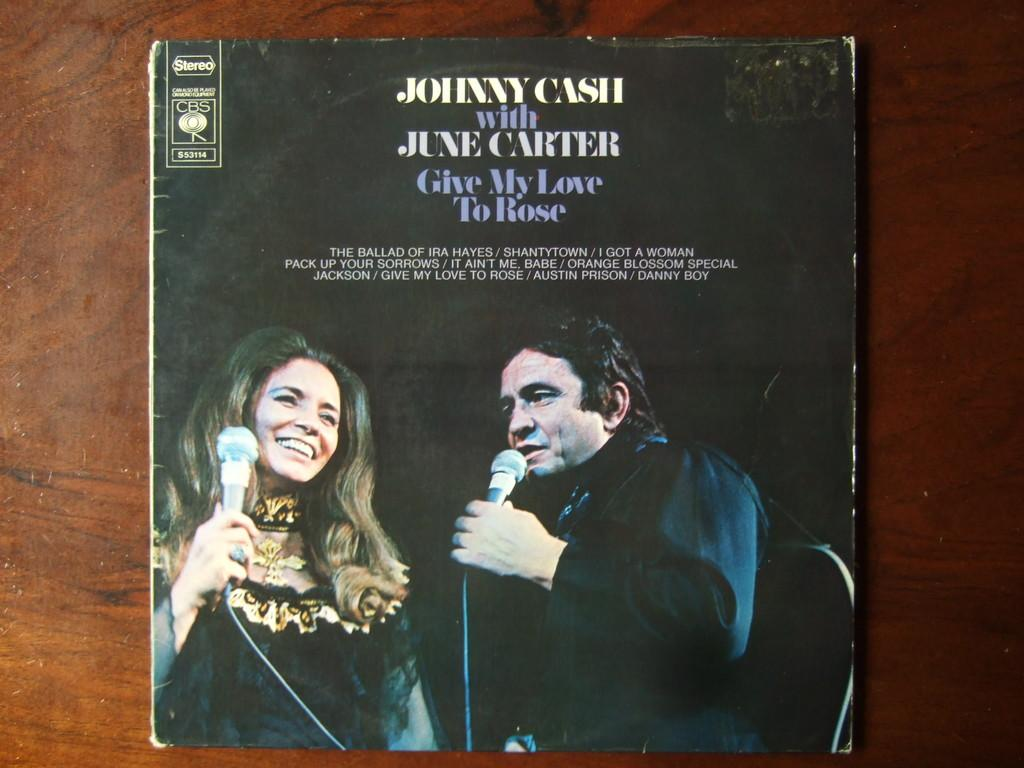<image>
Write a terse but informative summary of the picture. The cover of the album Give my love to rose by johnny cash and june carter. 